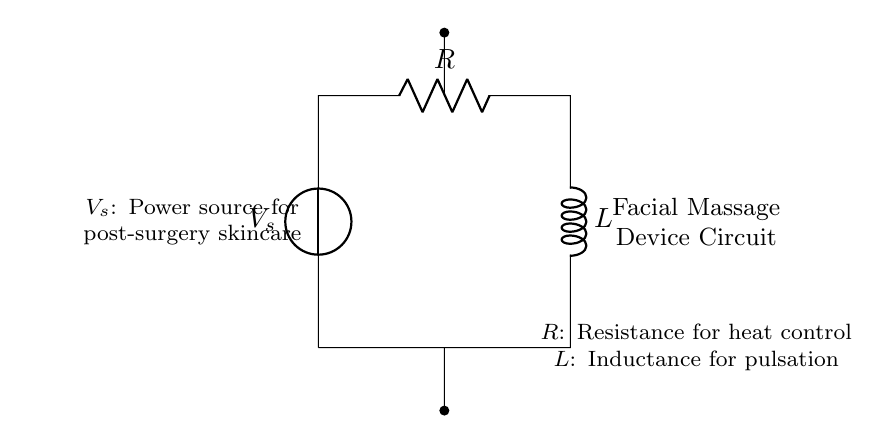What is the power source for this circuit? The power source is denoted as V_s in the circuit and provides the necessary voltage for the device.
Answer: V_s What component provides heat control in the circuit? The heat control is managed by the resistor, labeled as R, which regulates the amount of heat generated during the operation.
Answer: R What component is responsible for pulsation in the facial massage device? The inductance for pulsation is provided by the inductor, labeled as L, which influences the current flow in the circuit and creates pulsating effects.
Answer: L What type of circuit is represented in the diagram? This circuit is a Resistor-Inductor (RL) circuit, which includes a resistor and an inductor working in series with a voltage source.
Answer: Resistor-Inductor How do the resistor and inductor work together in this circuit? The resistor controls heat generation while the inductor creates a pulsating current. Together, they ensure the device operates effectively for skincare post-surgery.
Answer: They control heat and create pulsation 